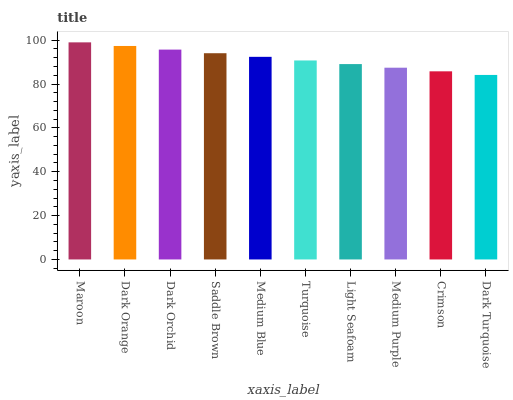Is Dark Orange the minimum?
Answer yes or no. No. Is Dark Orange the maximum?
Answer yes or no. No. Is Maroon greater than Dark Orange?
Answer yes or no. Yes. Is Dark Orange less than Maroon?
Answer yes or no. Yes. Is Dark Orange greater than Maroon?
Answer yes or no. No. Is Maroon less than Dark Orange?
Answer yes or no. No. Is Medium Blue the high median?
Answer yes or no. Yes. Is Turquoise the low median?
Answer yes or no. Yes. Is Turquoise the high median?
Answer yes or no. No. Is Dark Orange the low median?
Answer yes or no. No. 